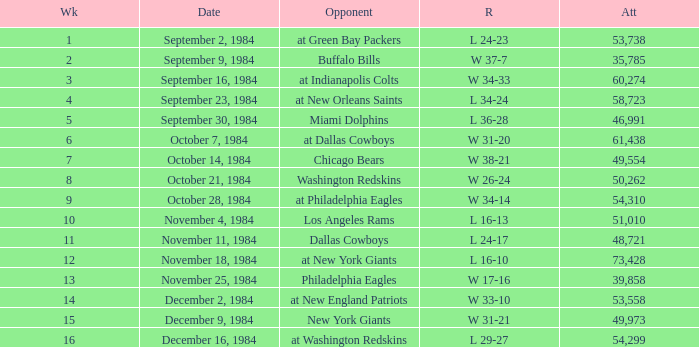What is the sum of attendance when the result was l 16-13? 51010.0. 